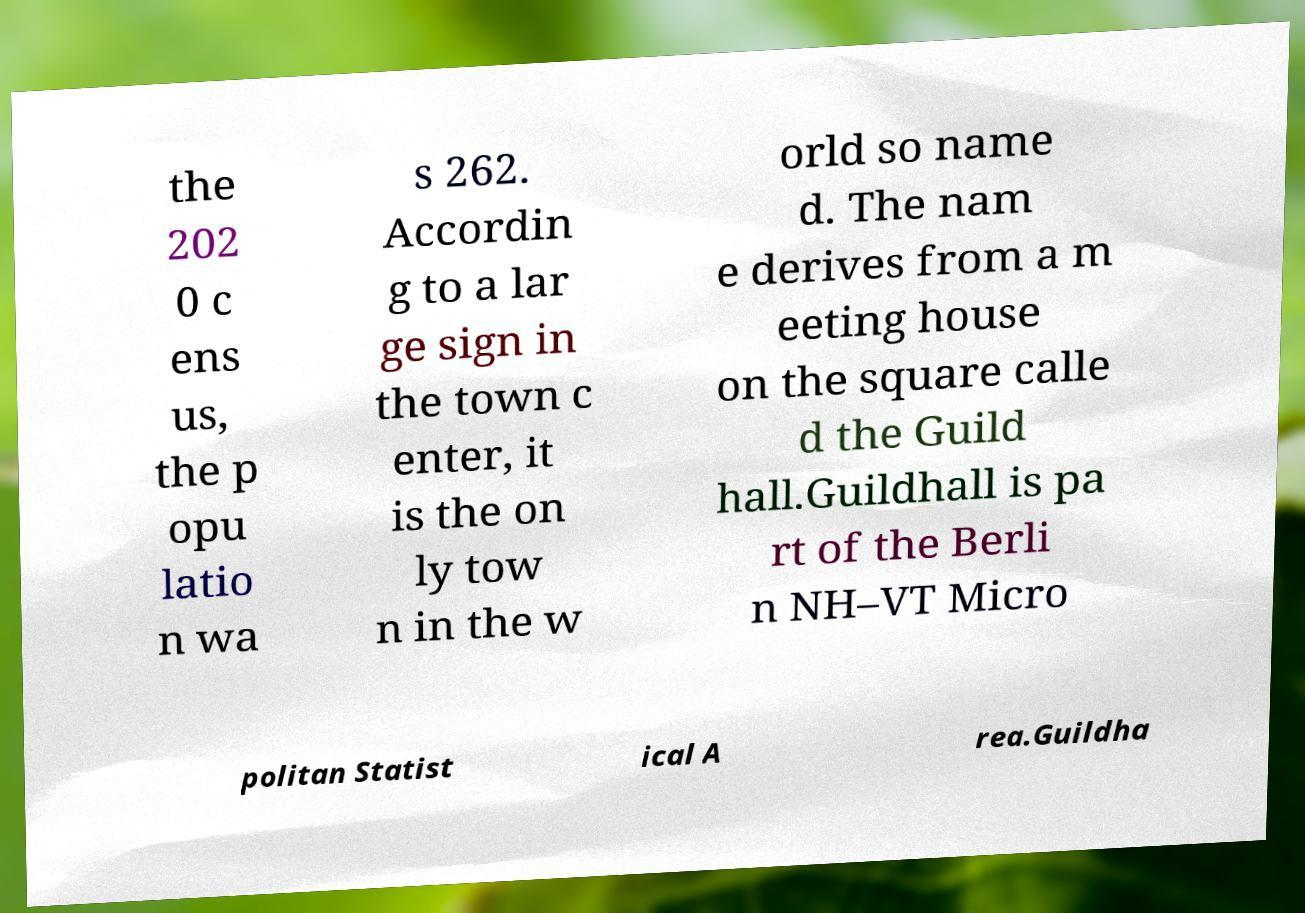There's text embedded in this image that I need extracted. Can you transcribe it verbatim? the 202 0 c ens us, the p opu latio n wa s 262. Accordin g to a lar ge sign in the town c enter, it is the on ly tow n in the w orld so name d. The nam e derives from a m eeting house on the square calle d the Guild hall.Guildhall is pa rt of the Berli n NH–VT Micro politan Statist ical A rea.Guildha 